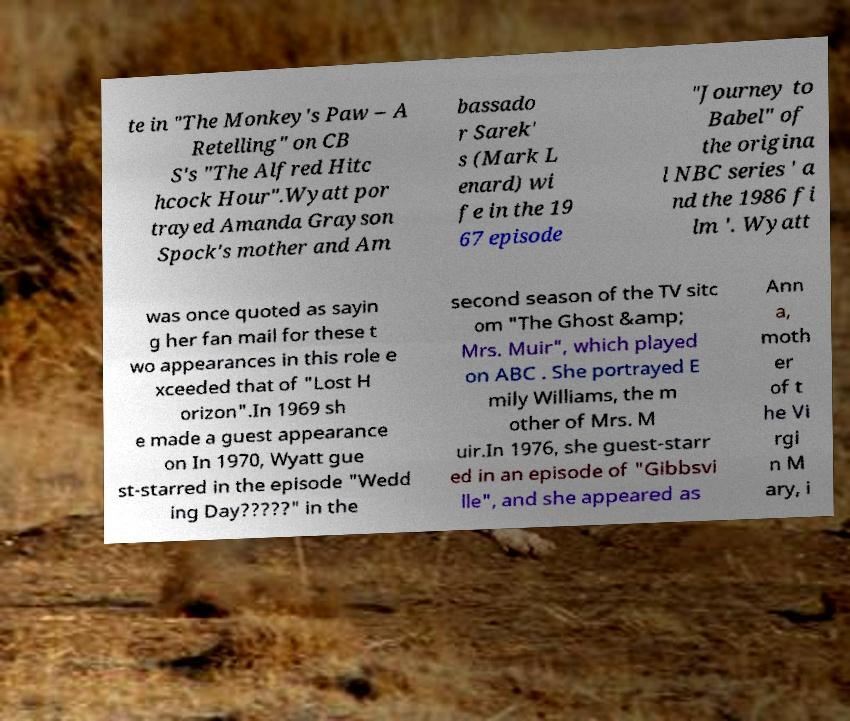For documentation purposes, I need the text within this image transcribed. Could you provide that? te in "The Monkey's Paw – A Retelling" on CB S's "The Alfred Hitc hcock Hour".Wyatt por trayed Amanda Grayson Spock's mother and Am bassado r Sarek' s (Mark L enard) wi fe in the 19 67 episode "Journey to Babel" of the origina l NBC series ' a nd the 1986 fi lm '. Wyatt was once quoted as sayin g her fan mail for these t wo appearances in this role e xceeded that of "Lost H orizon".In 1969 sh e made a guest appearance on In 1970, Wyatt gue st-starred in the episode "Wedd ing Day?????" in the second season of the TV sitc om "The Ghost &amp; Mrs. Muir", which played on ABC . She portrayed E mily Williams, the m other of Mrs. M uir.In 1976, she guest-starr ed in an episode of "Gibbsvi lle", and she appeared as Ann a, moth er of t he Vi rgi n M ary, i 